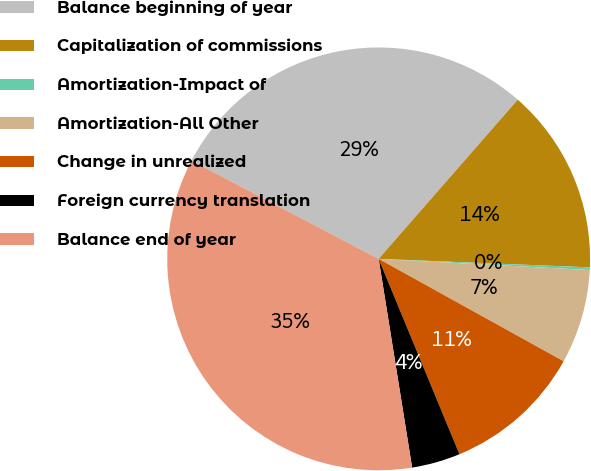<chart> <loc_0><loc_0><loc_500><loc_500><pie_chart><fcel>Balance beginning of year<fcel>Capitalization of commissions<fcel>Amortization-Impact of<fcel>Amortization-All Other<fcel>Change in unrealized<fcel>Foreign currency translation<fcel>Balance end of year<nl><fcel>28.74%<fcel>14.21%<fcel>0.2%<fcel>7.21%<fcel>10.71%<fcel>3.71%<fcel>35.23%<nl></chart> 